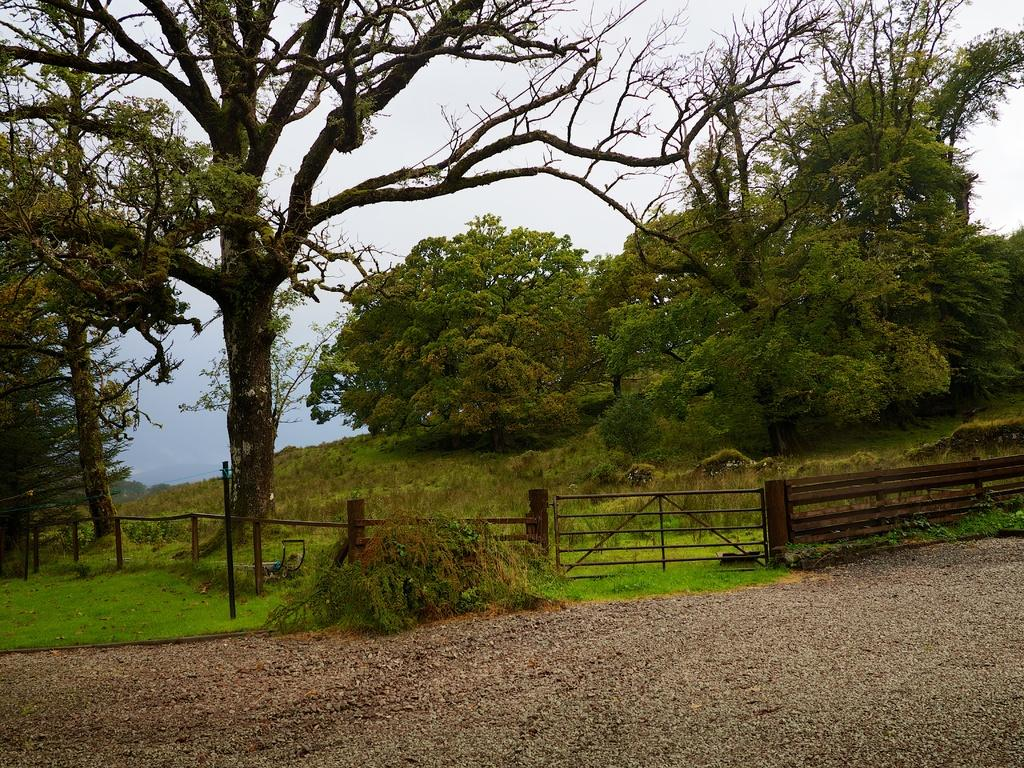What type of vegetation can be seen in the image? There are trees in the image. What structure is visible in the image? There is a fence in the image. What is covering the ground in the image? Grass is present on the ground in the image. What is the condition of the sky in the image? The sky is cloudy in the image. Where are the grapes placed on the tray in the image? There are no grapes or tray present in the image. What sound do the bells make in the image? There are no bells present in the image. 